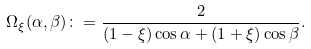<formula> <loc_0><loc_0><loc_500><loc_500>\Omega _ { \xi } ( \alpha , \beta ) \colon = \frac { 2 } { ( 1 - \xi ) \cos \alpha + ( 1 + \xi ) \cos \beta } .</formula> 